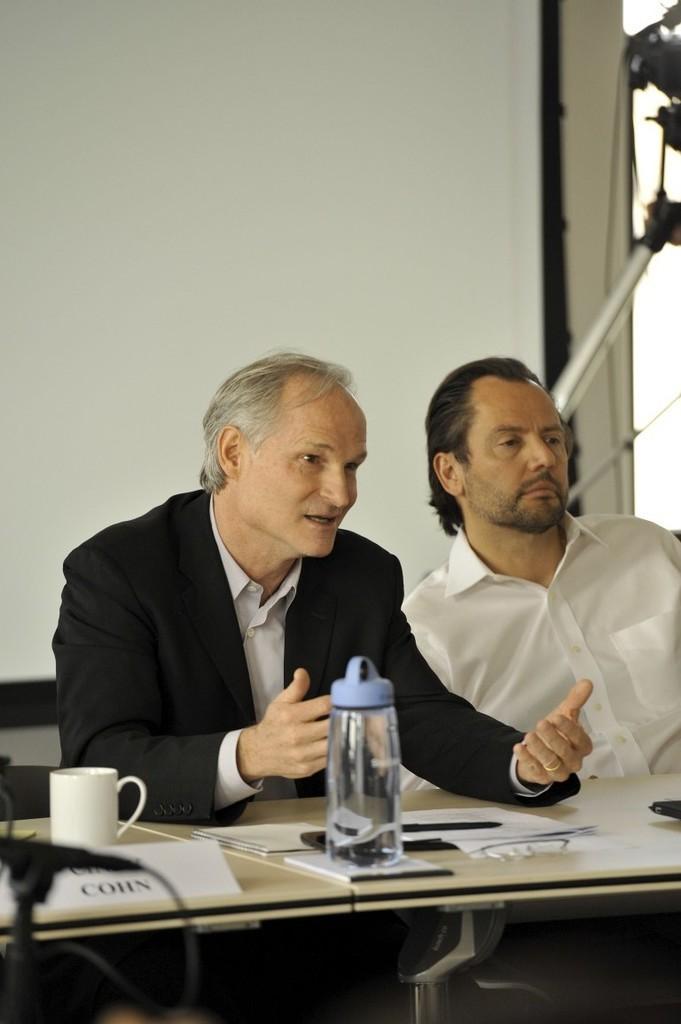Can you describe this image briefly? The picture may be from a meeting or a press conference. In the picture a person is sitting in front a table and talking something, he is in center of the image. On the right a man in white shirt is seated. On the foreground there are tables, on the table there is a nameplate, cup, bottles, book. In the background there is a white curtain. 